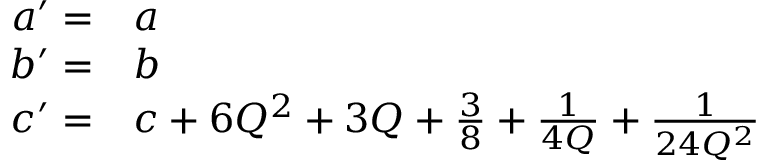Convert formula to latex. <formula><loc_0><loc_0><loc_500><loc_500>\begin{array} { r l } { a ^ { \prime } = } & a } \\ { b ^ { \prime } = } & b } \\ { c ^ { \prime } = } & c + 6 Q ^ { 2 } + 3 Q + \frac { 3 } { 8 } + \frac { 1 } { 4 Q } + \frac { 1 } { 2 4 Q ^ { 2 } } } \end{array}</formula> 